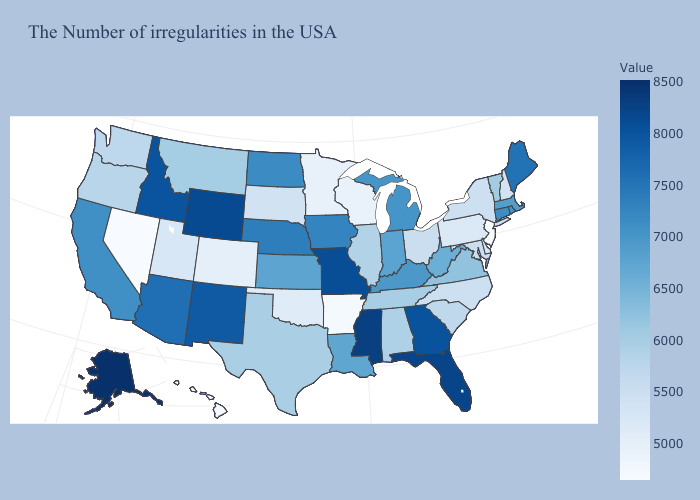Does Tennessee have a lower value than Maryland?
Keep it brief. No. Does Montana have the lowest value in the West?
Keep it brief. No. Does Nebraska have the highest value in the MidWest?
Concise answer only. No. Which states have the lowest value in the USA?
Concise answer only. New Jersey. 